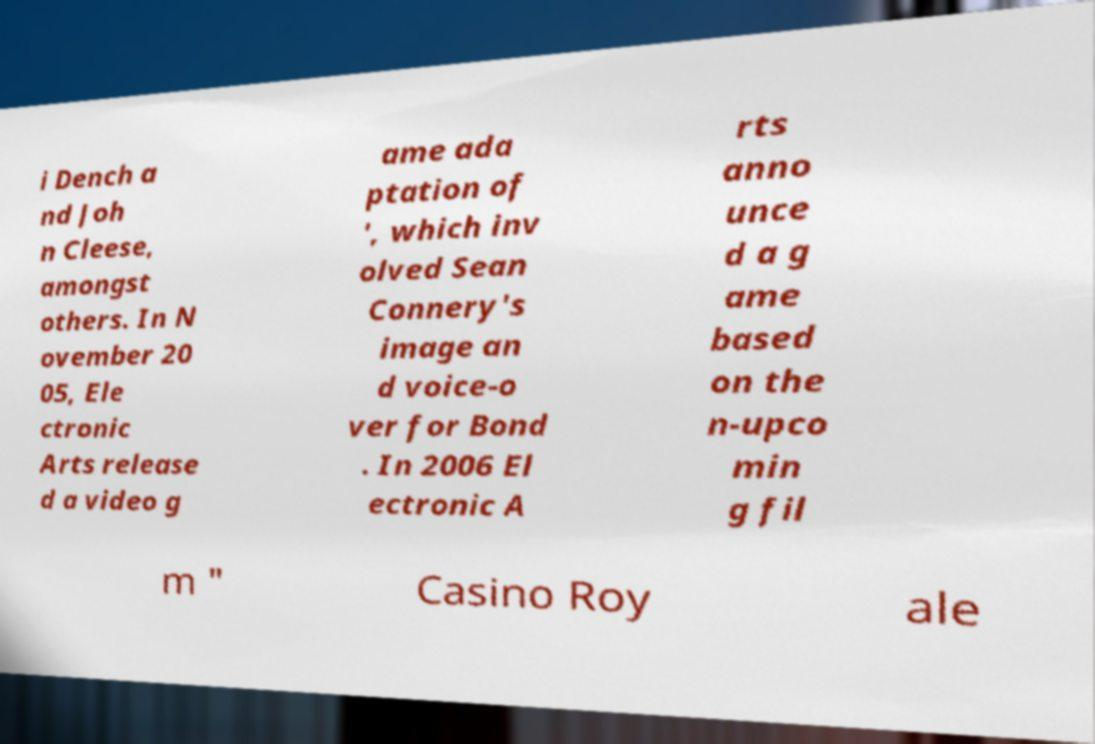Could you assist in decoding the text presented in this image and type it out clearly? i Dench a nd Joh n Cleese, amongst others. In N ovember 20 05, Ele ctronic Arts release d a video g ame ada ptation of ', which inv olved Sean Connery's image an d voice-o ver for Bond . In 2006 El ectronic A rts anno unce d a g ame based on the n-upco min g fil m " Casino Roy ale 